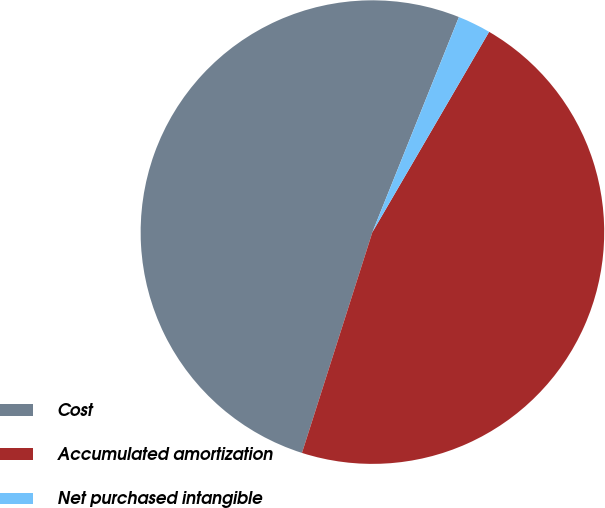Convert chart. <chart><loc_0><loc_0><loc_500><loc_500><pie_chart><fcel>Cost<fcel>Accumulated amortization<fcel>Net purchased intangible<nl><fcel>51.17%<fcel>46.52%<fcel>2.31%<nl></chart> 